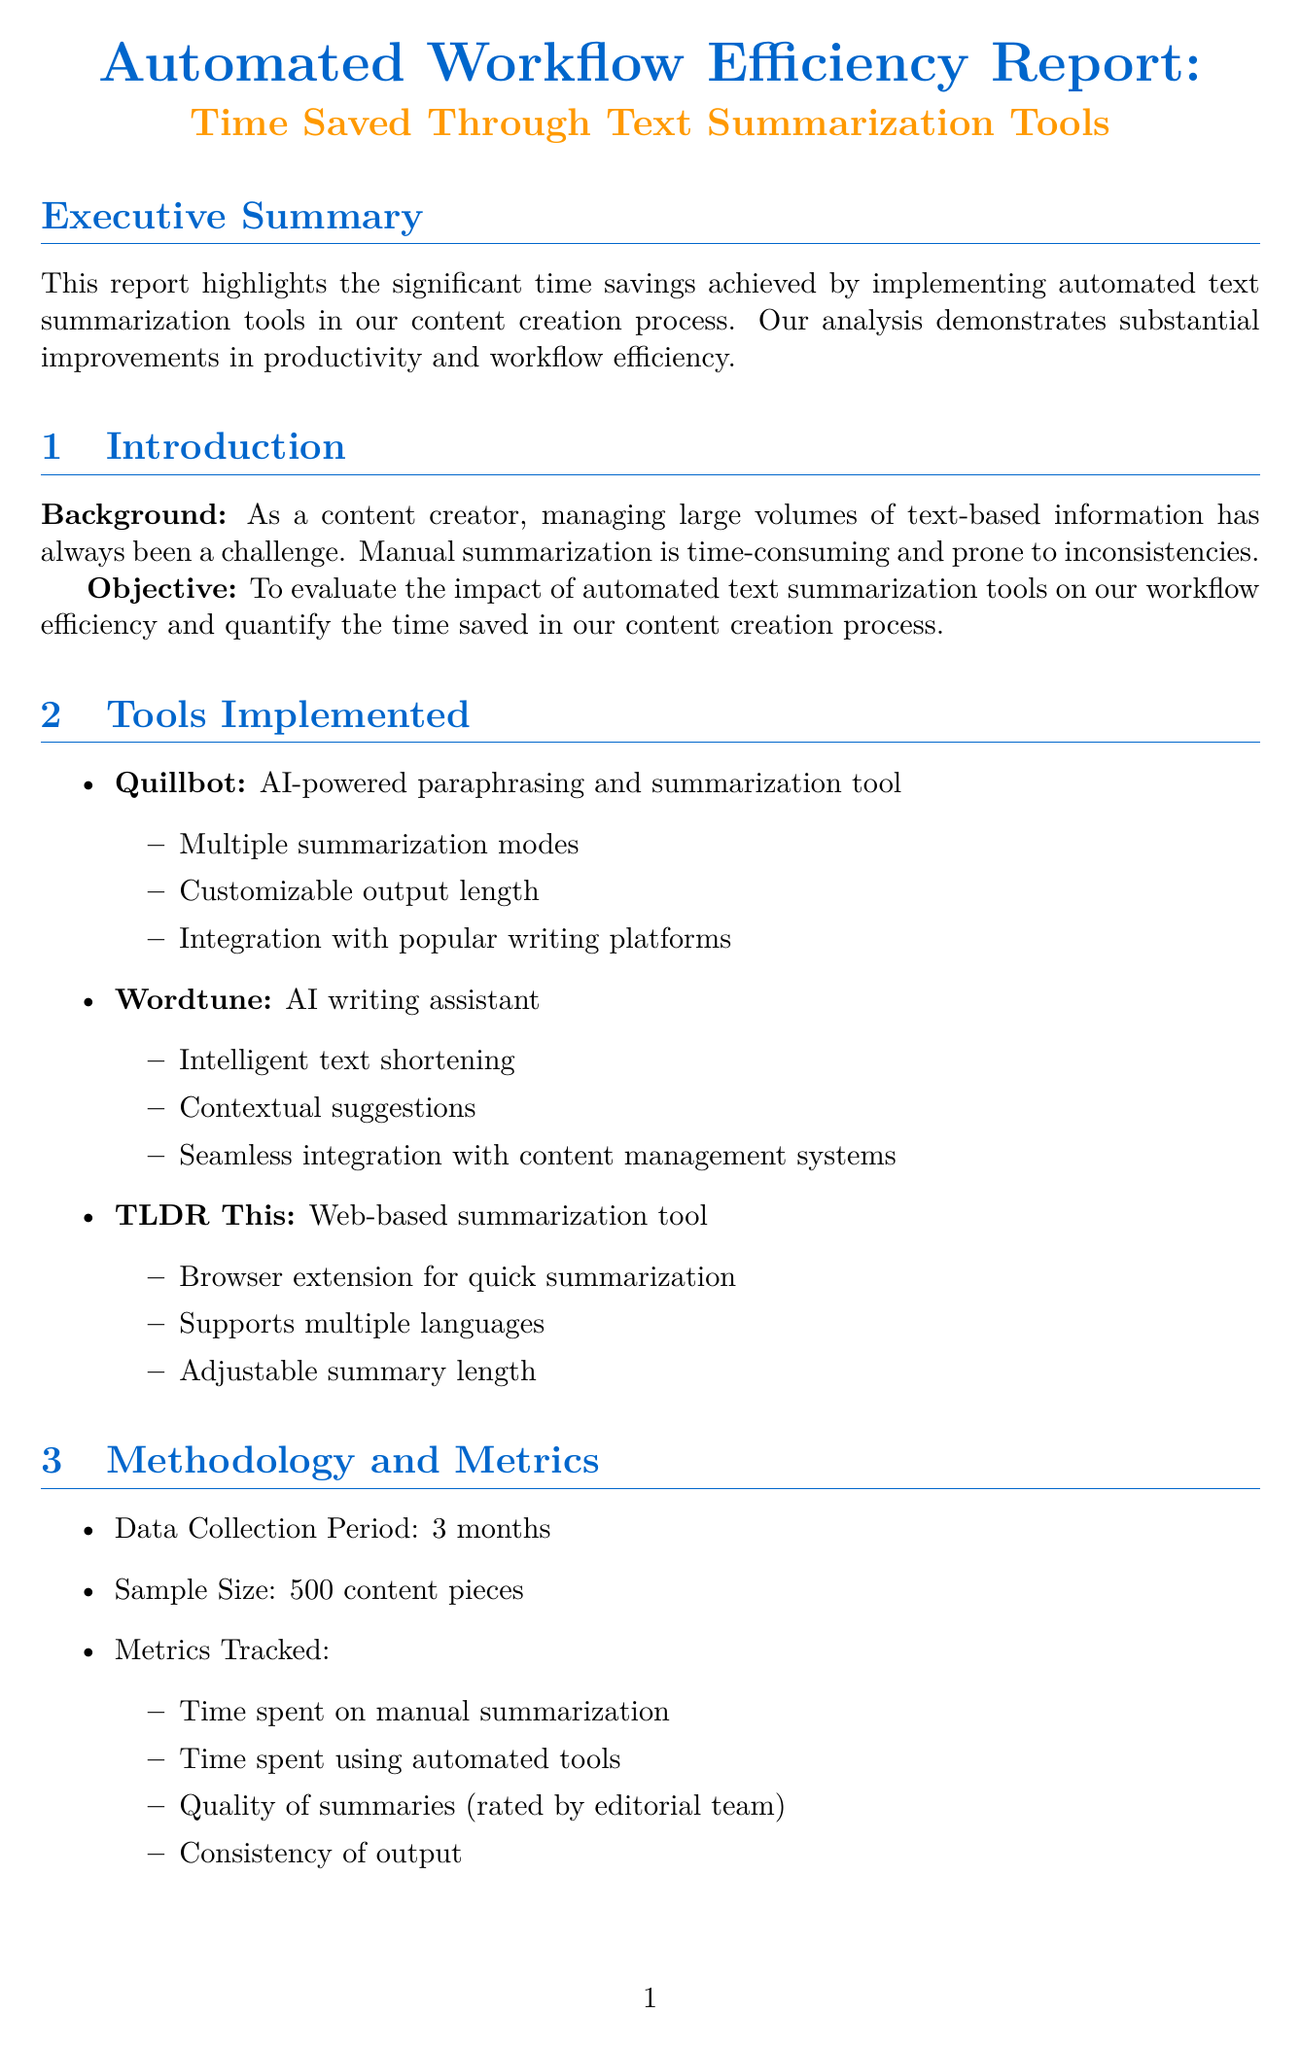What is the report title? The report title is stated at the beginning of the document, which is "Automated Workflow Efficiency Report: Time Saved Through Text Summarization Tools."
Answer: Automated Workflow Efficiency Report: Time Saved Through Text Summarization Tools What is the average time saved per content piece? The document specifies the average time saved per piece as mentioned in the results section.
Answer: 45 minutes How many content pieces were evaluated? The sample size is detailed in the methodology section of the report.
Answer: 500 content pieces What was the productivity increase percentage? The productivity increase is directly stated in the results section of the document.
Answer: 32% Which tool was used for bulk summarization of news articles? The case studies provide information on the solutions implemented, revealing which tools were used for specific challenges.
Answer: Quillbot What was the editor satisfaction score? The quality metrics include the editor satisfaction score, which indicates the assessment of the automated summaries.
Answer: 4.2/5 What is one of the challenges mentioned regarding tool implementation? The challenges and limitations section outlines difficulties faced, including initial team learning curves and needs for manual adjustments.
Answer: Initial learning curve for team members What is the return on investment percentage? The cost analysis provides the financial benefits realized, including the return on investment figure for the tools.
Answer: 1150% What future plan involves team training? Future plans state intentions regarding team development and operational improvements.
Answer: Invest in team training for advanced features of summarization tools 